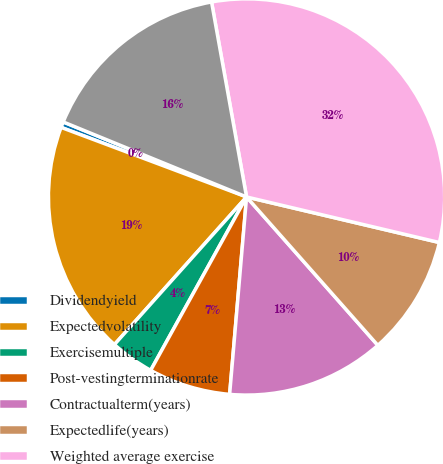<chart> <loc_0><loc_0><loc_500><loc_500><pie_chart><fcel>Dividendyield<fcel>Expectedvolatility<fcel>Exercisemultiple<fcel>Post-vestingterminationrate<fcel>Contractualterm(years)<fcel>Expectedlife(years)<fcel>Weighted average exercise<fcel>Weighted average fair value of<nl><fcel>0.47%<fcel>19.09%<fcel>3.58%<fcel>6.68%<fcel>12.89%<fcel>9.78%<fcel>31.52%<fcel>15.99%<nl></chart> 